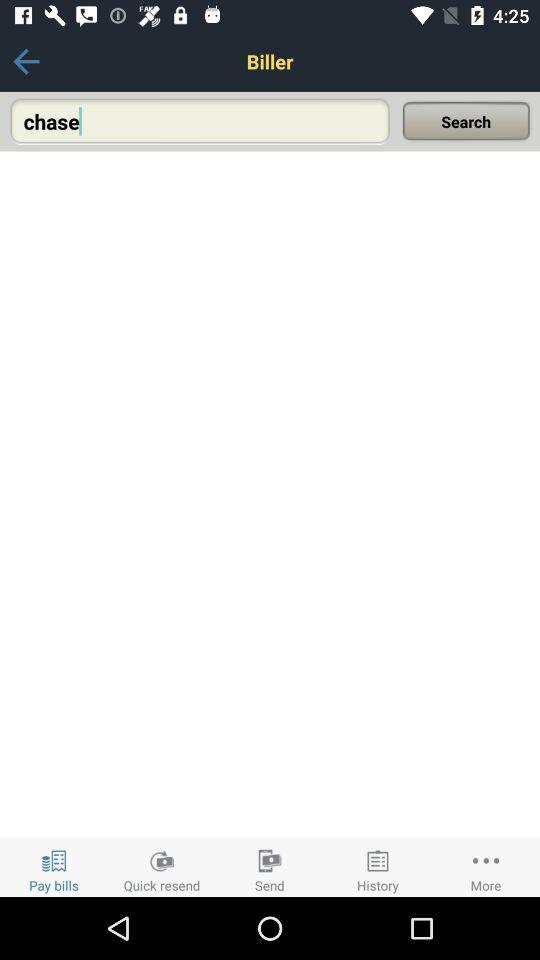How many results are there for "chase"?
When the provided information is insufficient, respond with <no answer>. <no answer> 